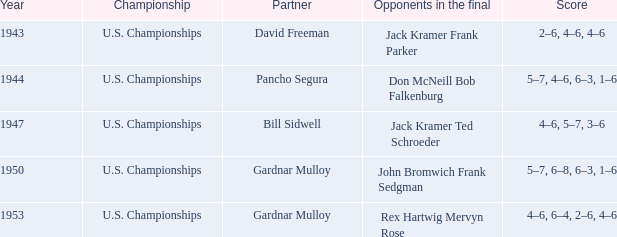What score did opponents achieve in the final of john bromwich frank sedgman? 5–7, 6–8, 6–3, 1–6. 